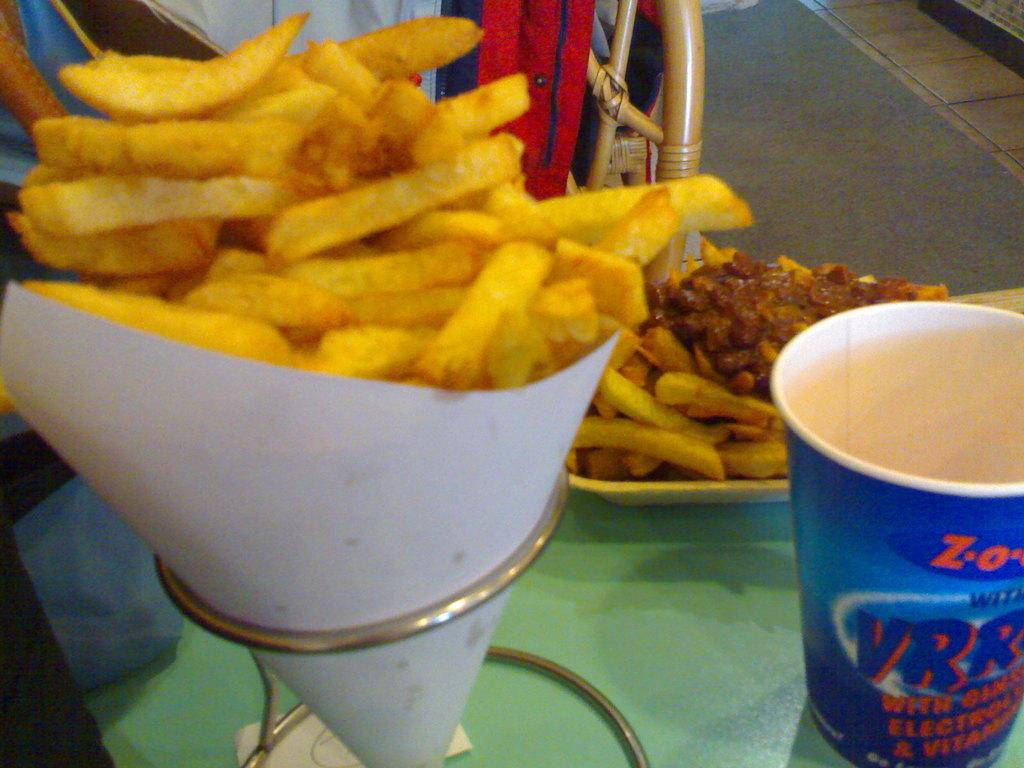What type of food is visible in the image? The specific type of food is not mentioned, but there is food present in the image. What is the glass used for in the image? The purpose of the glass is not specified, but it is visible in the image. On what surface are the food and glass placed? The food and glass are both placed on a surface in the image. What type of coat is the food wearing in the image? The food is not wearing a coat in the image, as food does not wear clothing. 